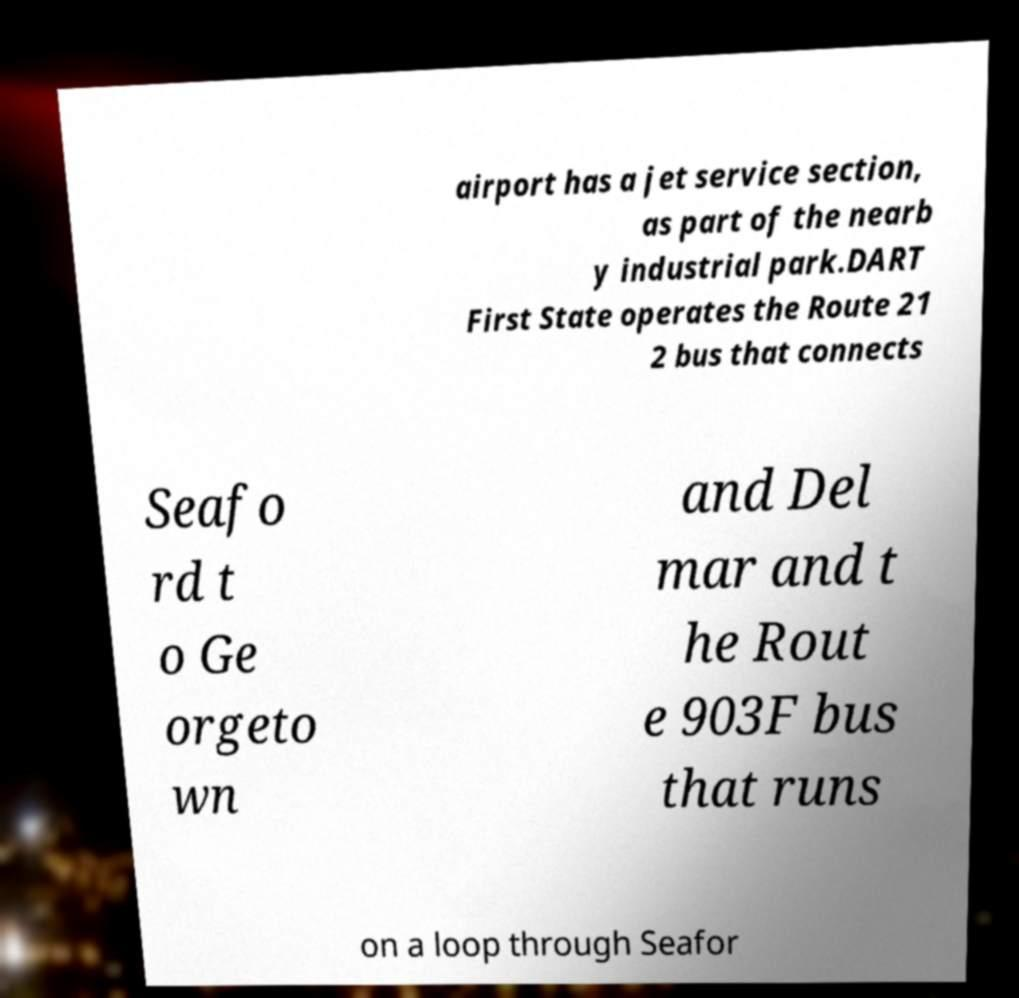Could you extract and type out the text from this image? airport has a jet service section, as part of the nearb y industrial park.DART First State operates the Route 21 2 bus that connects Seafo rd t o Ge orgeto wn and Del mar and t he Rout e 903F bus that runs on a loop through Seafor 